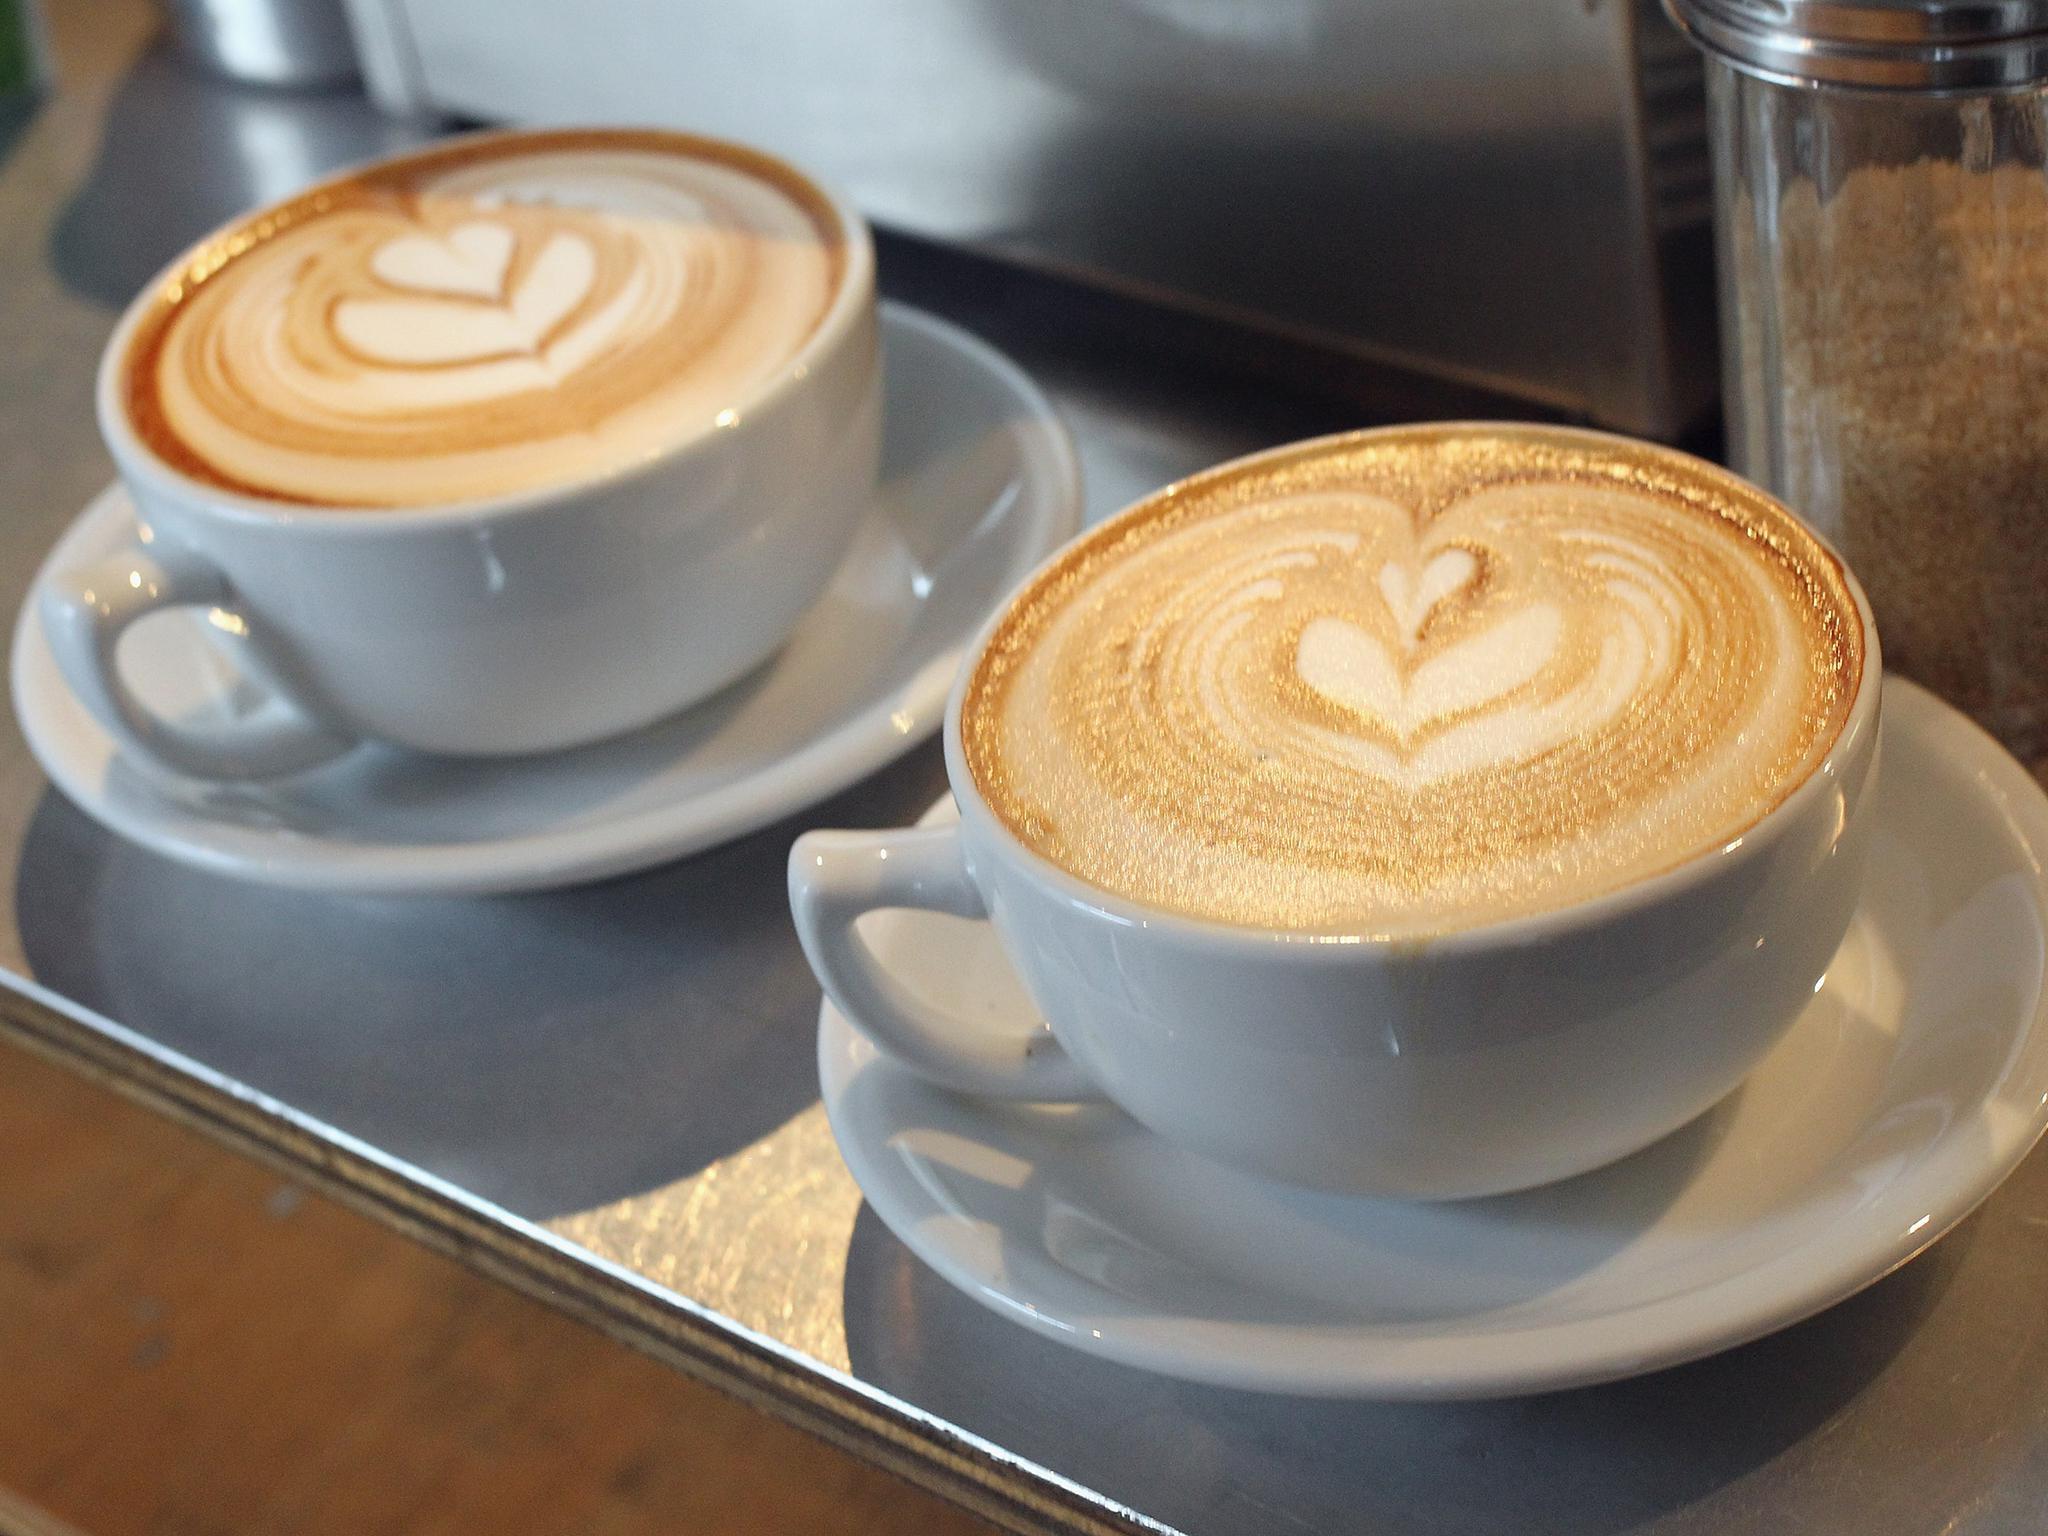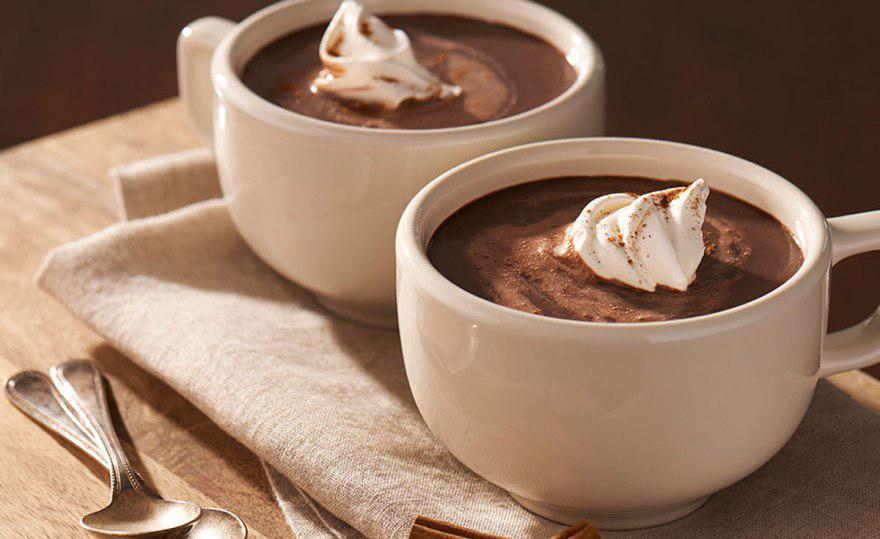The first image is the image on the left, the second image is the image on the right. Analyze the images presented: Is the assertion "Two of the mugs are set on one tray." valid? Answer yes or no. Yes. The first image is the image on the left, the second image is the image on the right. Evaluate the accuracy of this statement regarding the images: "Each image shows two matching hot drinks in cups, one of the pairs, cups of coffee with heart shaped froth designs.". Is it true? Answer yes or no. Yes. 